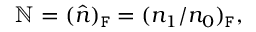Convert formula to latex. <formula><loc_0><loc_0><loc_500><loc_500>\mathbb { N } = ( \hat { n } ) _ { F } = ( n _ { 1 } / n _ { 0 } ) _ { F } ,</formula> 